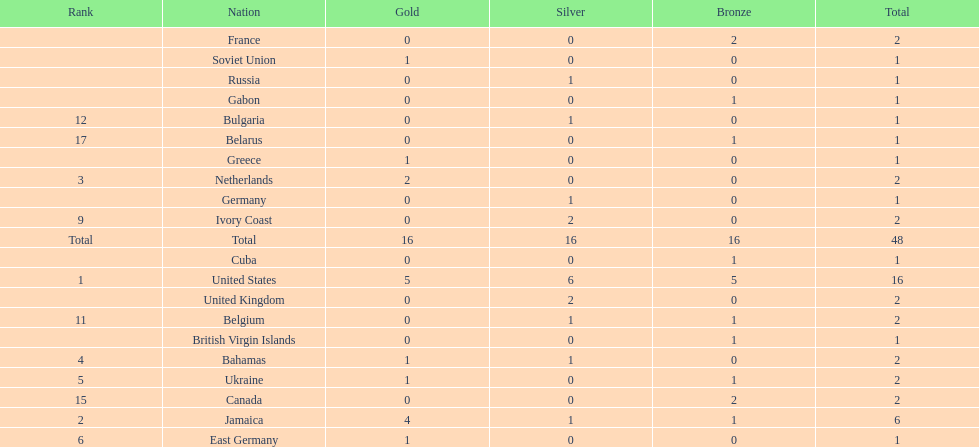How many nations won at least two gold medals? 3. 